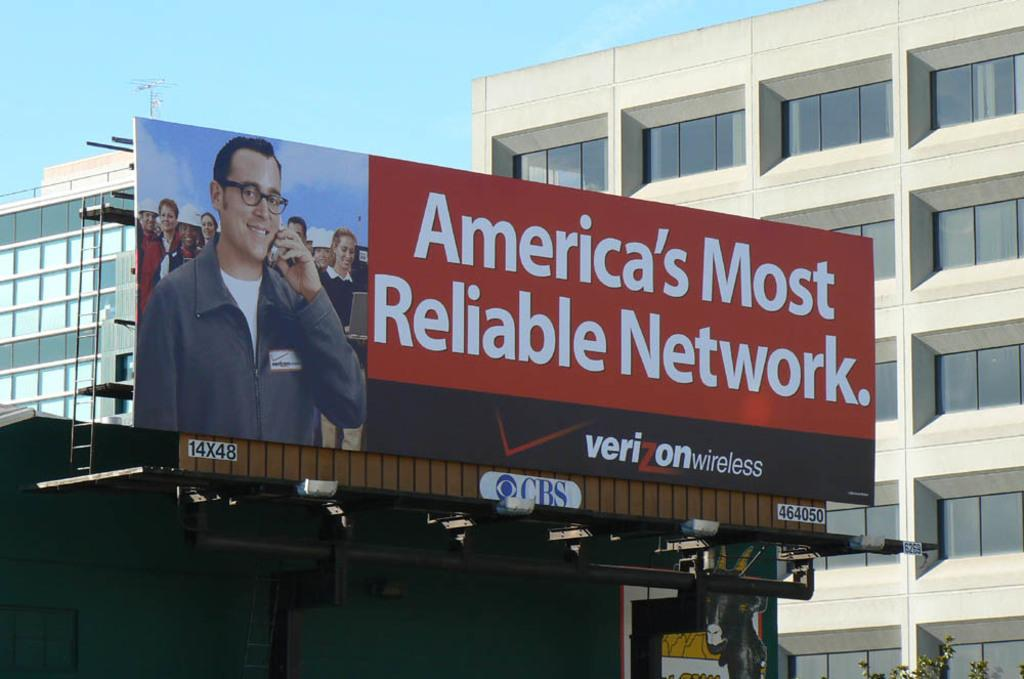<image>
Render a clear and concise summary of the photo. A billboard advertises Verizon wireless as America's most reliable network. 